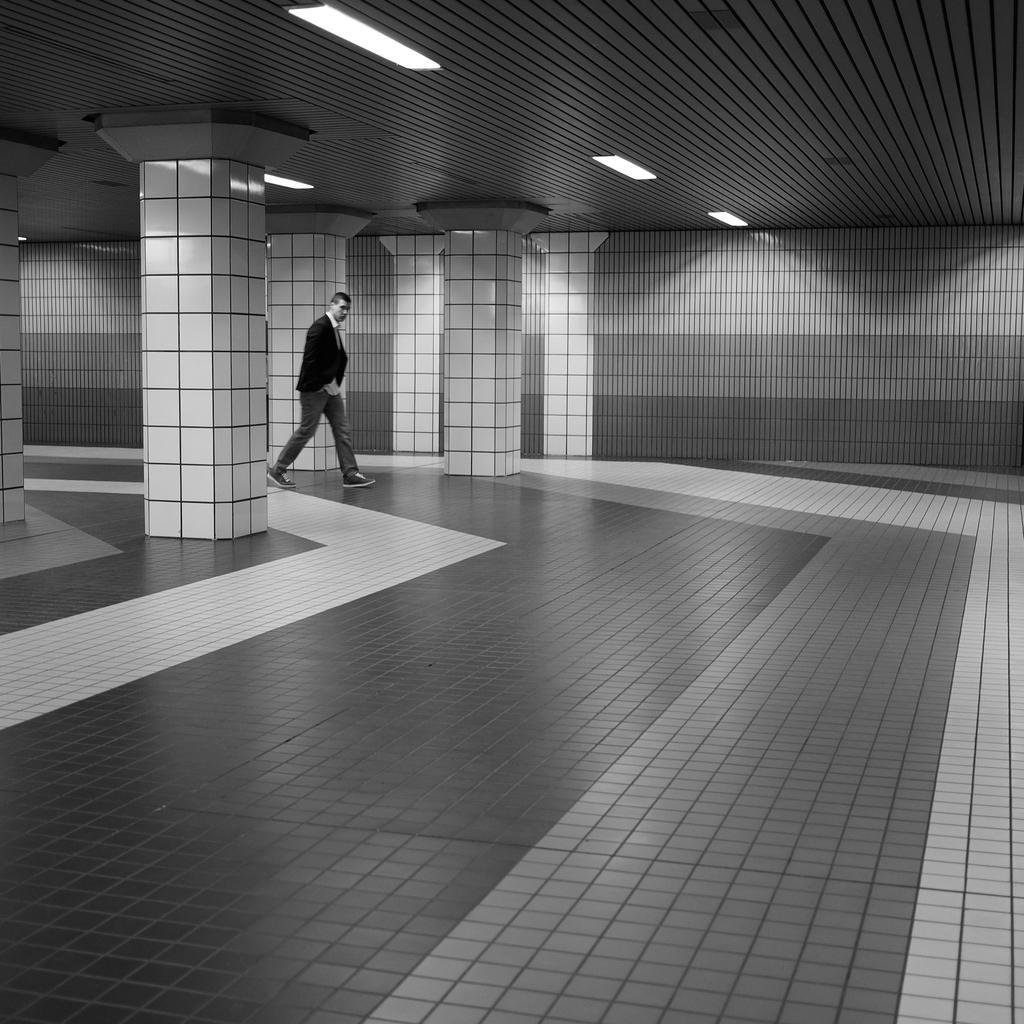In one or two sentences, can you explain what this image depicts? In this image we can see a person is walking. We can see the interior of the building. There are few lights attached to the roof. 